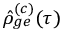Convert formula to latex. <formula><loc_0><loc_0><loc_500><loc_500>\hat { \rho } _ { g e } ^ { ( c ) } ( \tau )</formula> 